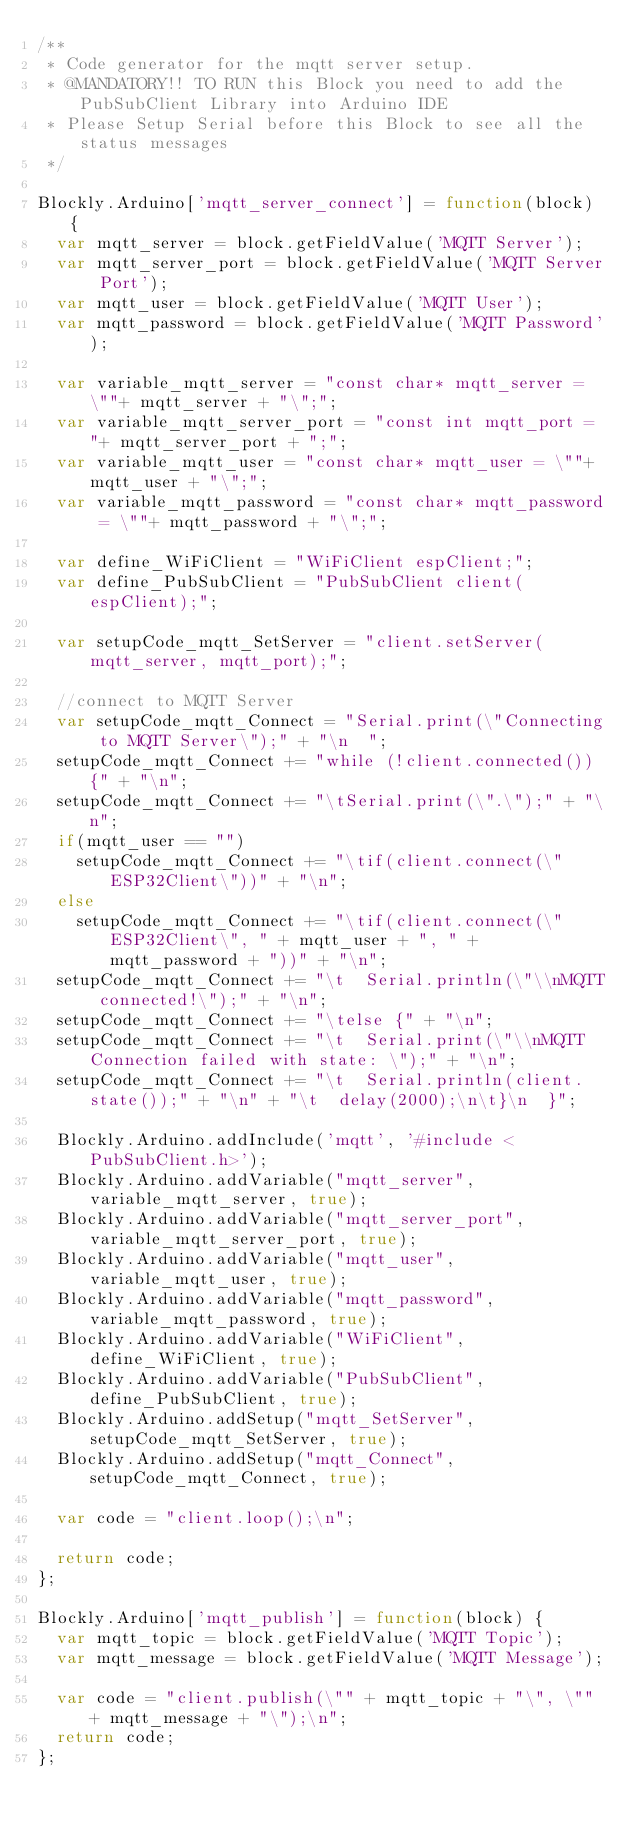<code> <loc_0><loc_0><loc_500><loc_500><_JavaScript_>/**
 * Code generator for the mqtt server setup.
 * @MANDATORY!! TO RUN this Block you need to add the PubSubClient Library into Arduino IDE
 * Please Setup Serial before this Block to see all the status messages
 */
 
Blockly.Arduino['mqtt_server_connect'] = function(block) {
  var mqtt_server = block.getFieldValue('MQTT Server');
  var mqtt_server_port = block.getFieldValue('MQTT Server Port');
  var mqtt_user = block.getFieldValue('MQTT User');
  var mqtt_password = block.getFieldValue('MQTT Password');
  
  var variable_mqtt_server = "const char* mqtt_server = \""+ mqtt_server + "\";";
  var variable_mqtt_server_port = "const int mqtt_port = "+ mqtt_server_port + ";";
  var variable_mqtt_user = "const char* mqtt_user = \""+ mqtt_user + "\";";
  var variable_mqtt_password = "const char* mqtt_password = \""+ mqtt_password + "\";";
  
  var define_WiFiClient = "WiFiClient espClient;";
  var define_PubSubClient = "PubSubClient client(espClient);";
  
  var setupCode_mqtt_SetServer = "client.setServer(mqtt_server, mqtt_port);";
  
  //connect to MQTT Server
  var setupCode_mqtt_Connect = "Serial.print(\"Connecting to MQTT Server\");" + "\n  ";
  setupCode_mqtt_Connect += "while (!client.connected()) {" + "\n";
  setupCode_mqtt_Connect += "\tSerial.print(\".\");" + "\n";
  if(mqtt_user == "")
	  setupCode_mqtt_Connect += "\tif(client.connect(\"ESP32Client\"))" + "\n";
  else
	  setupCode_mqtt_Connect += "\tif(client.connect(\"ESP32Client\", " + mqtt_user + ", " + mqtt_password + "))" + "\n";
  setupCode_mqtt_Connect += "\t  Serial.println(\"\\nMQTT connected!\");" + "\n";
  setupCode_mqtt_Connect += "\telse {" + "\n";
  setupCode_mqtt_Connect += "\t  Serial.print(\"\\nMQTT Connection failed with state: \");" + "\n";
  setupCode_mqtt_Connect += "\t  Serial.println(client.state());" + "\n" + "\t  delay(2000);\n\t}\n  }";
  
  Blockly.Arduino.addInclude('mqtt', '#include <PubSubClient.h>');
  Blockly.Arduino.addVariable("mqtt_server", variable_mqtt_server, true);
  Blockly.Arduino.addVariable("mqtt_server_port", variable_mqtt_server_port, true);
  Blockly.Arduino.addVariable("mqtt_user", variable_mqtt_user, true);
  Blockly.Arduino.addVariable("mqtt_password", variable_mqtt_password, true);
  Blockly.Arduino.addVariable("WiFiClient", define_WiFiClient, true);
  Blockly.Arduino.addVariable("PubSubClient", define_PubSubClient, true);
  Blockly.Arduino.addSetup("mqtt_SetServer", setupCode_mqtt_SetServer, true);
  Blockly.Arduino.addSetup("mqtt_Connect", setupCode_mqtt_Connect, true);
  
  var code = "client.loop();\n";
  
  return code;
};

Blockly.Arduino['mqtt_publish'] = function(block) {
  var mqtt_topic = block.getFieldValue('MQTT Topic');
  var mqtt_message = block.getFieldValue('MQTT Message');
  
  var code = "client.publish(\"" + mqtt_topic + "\", \"" + mqtt_message + "\");\n";
  return code;
};</code> 